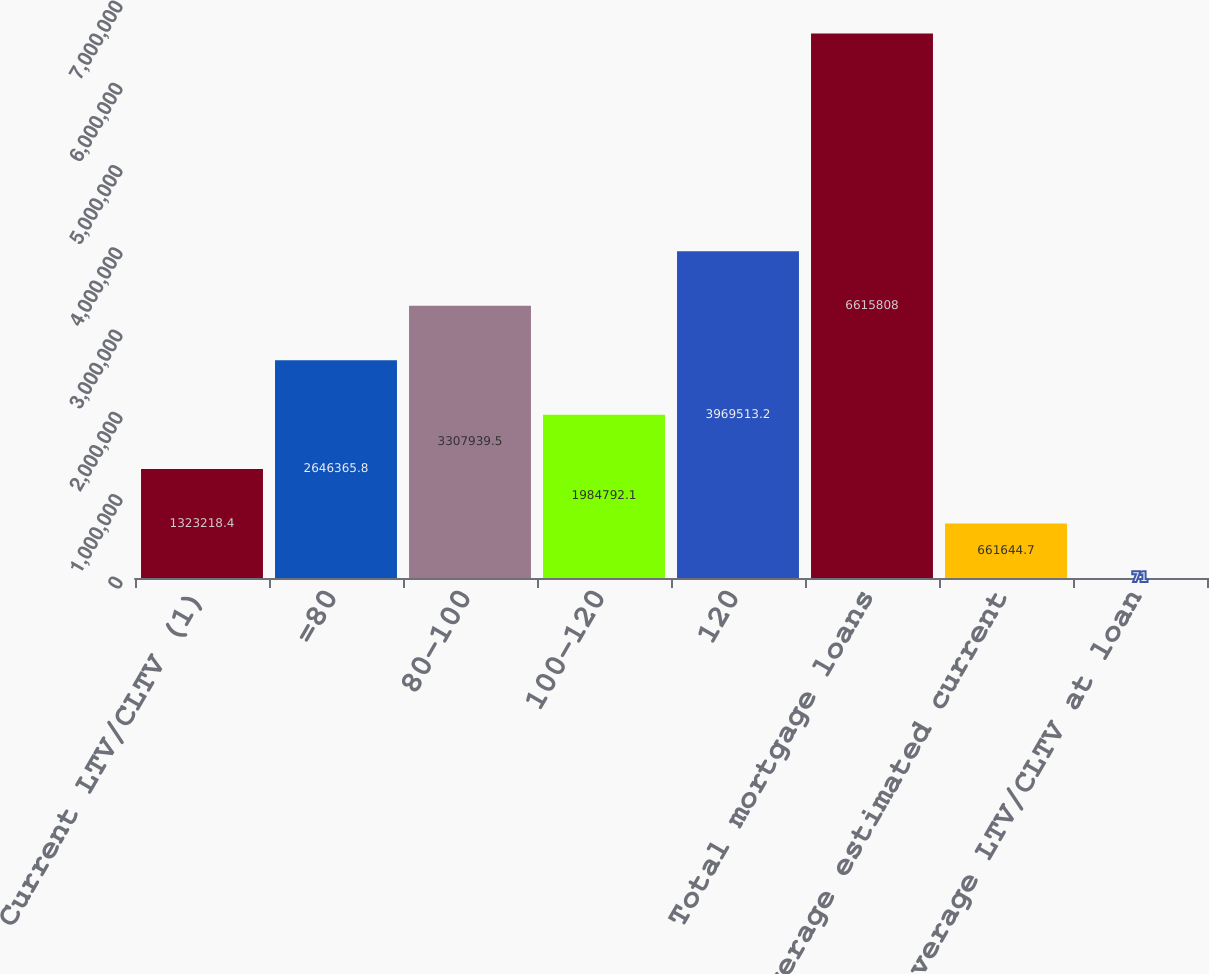Convert chart. <chart><loc_0><loc_0><loc_500><loc_500><bar_chart><fcel>Current LTV/CLTV (1)<fcel>=80<fcel>80-100<fcel>100-120<fcel>120<fcel>Total mortgage loans<fcel>Average estimated current<fcel>Average LTV/CLTV at loan<nl><fcel>1.32322e+06<fcel>2.64637e+06<fcel>3.30794e+06<fcel>1.98479e+06<fcel>3.96951e+06<fcel>6.61581e+06<fcel>661645<fcel>71<nl></chart> 